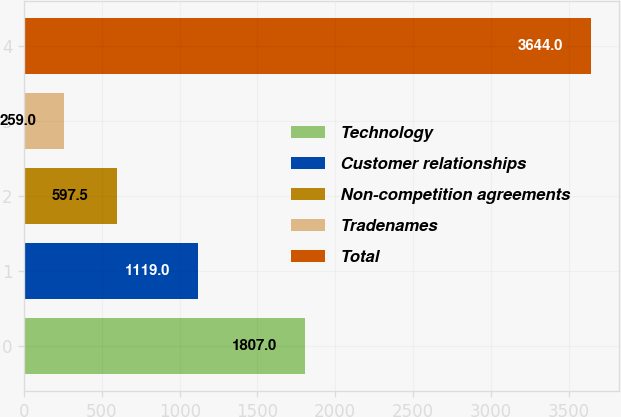<chart> <loc_0><loc_0><loc_500><loc_500><bar_chart><fcel>Technology<fcel>Customer relationships<fcel>Non-competition agreements<fcel>Tradenames<fcel>Total<nl><fcel>1807<fcel>1119<fcel>597.5<fcel>259<fcel>3644<nl></chart> 